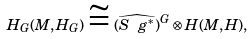Convert formula to latex. <formula><loc_0><loc_0><loc_500><loc_500>H _ { G } ( M , H _ { G } ) \cong ( \widehat { S \ g ^ { * } } ) ^ { G } \otimes H ( M , H ) ,</formula> 